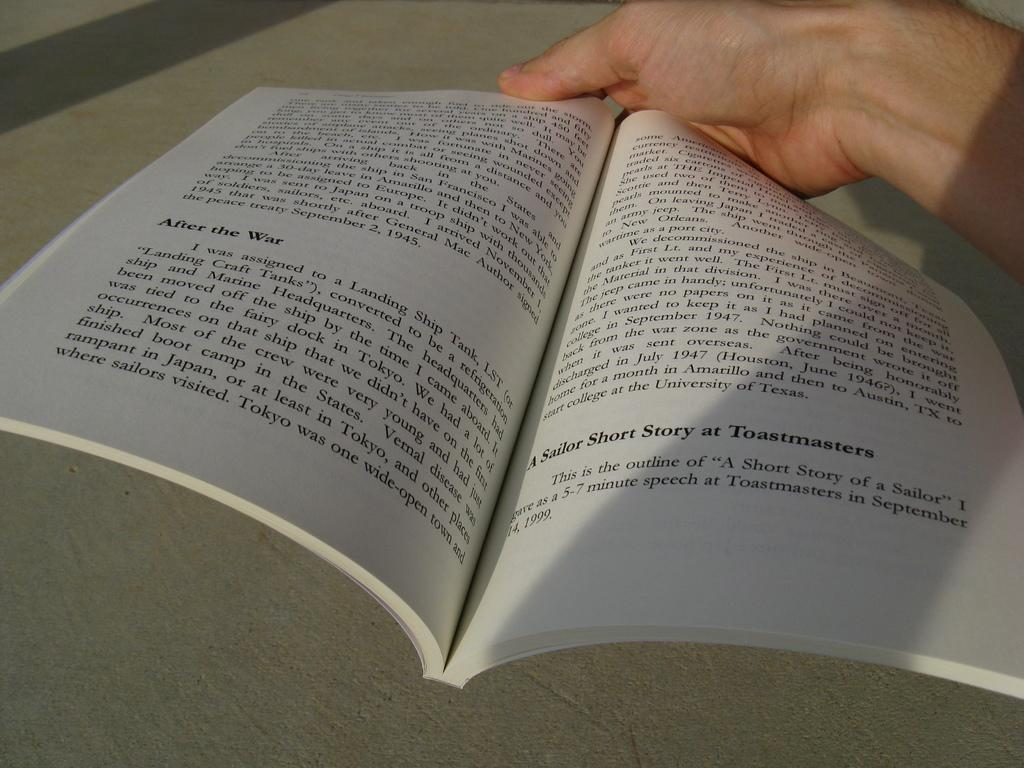<image>
Write a terse but informative summary of the picture. the word Toastmasters that is in a book 